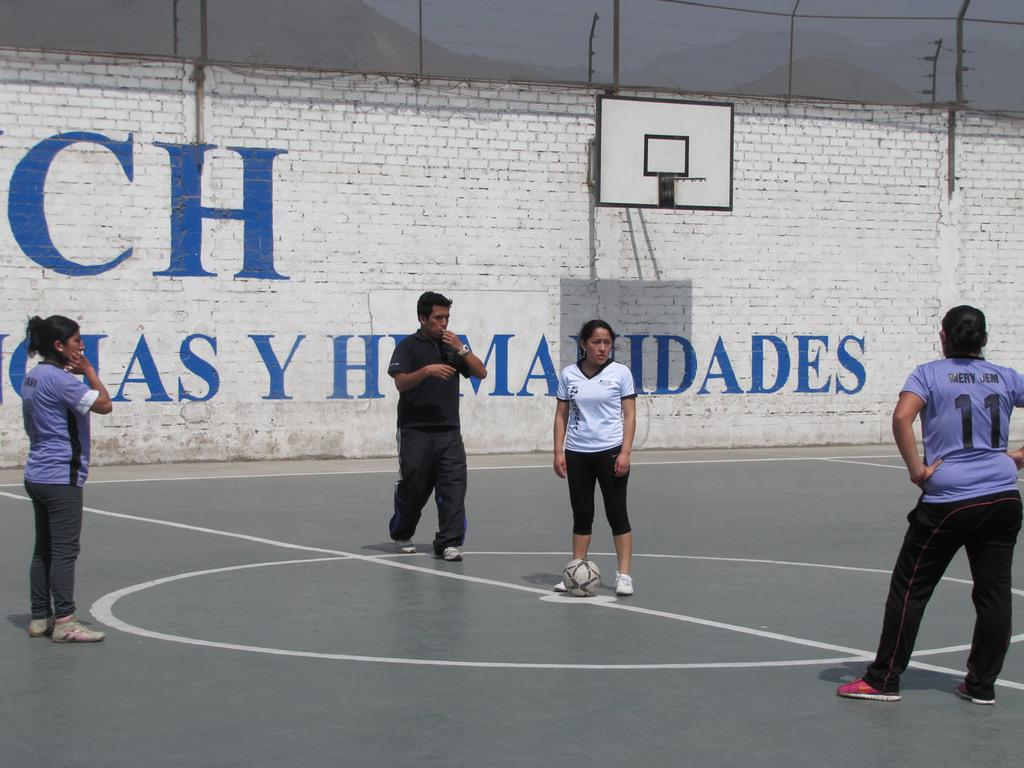How many people are present in the image? There are four people standing in the image. What activity might the people be engaged in, based on the presence of a basketball hoop? The people might be playing basketball, as there is a basketball hoop attached to a wall in the image. What type of barrier can be seen in the image? There is a fencing in the image. What type of natural landscape is visible in the image? There are hills visible in the image. What other objects can be seen in the image? There are cables and the sky is visible in the background of the image. What type of division is taking place in the image? There is no division taking place in the image. Can you see any jails or prison cells in the image? There are no jails or prison cells present in the image. 